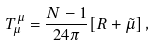Convert formula to latex. <formula><loc_0><loc_0><loc_500><loc_500>T _ { \mu } ^ { \mu } = \frac { N - 1 } { 2 4 \pi } [ R + \tilde { \mu } ] \, ,</formula> 